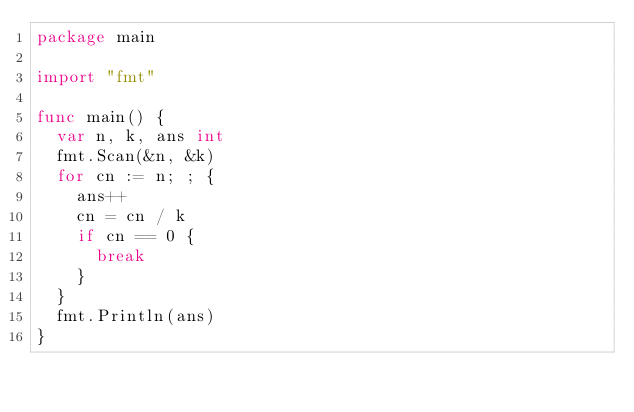Convert code to text. <code><loc_0><loc_0><loc_500><loc_500><_Go_>package main

import "fmt"

func main() {
	var n, k, ans int
	fmt.Scan(&n, &k)
	for cn := n; ; {
		ans++
		cn = cn / k
		if cn == 0 {
			break
		}
	}
	fmt.Println(ans)
}
</code> 